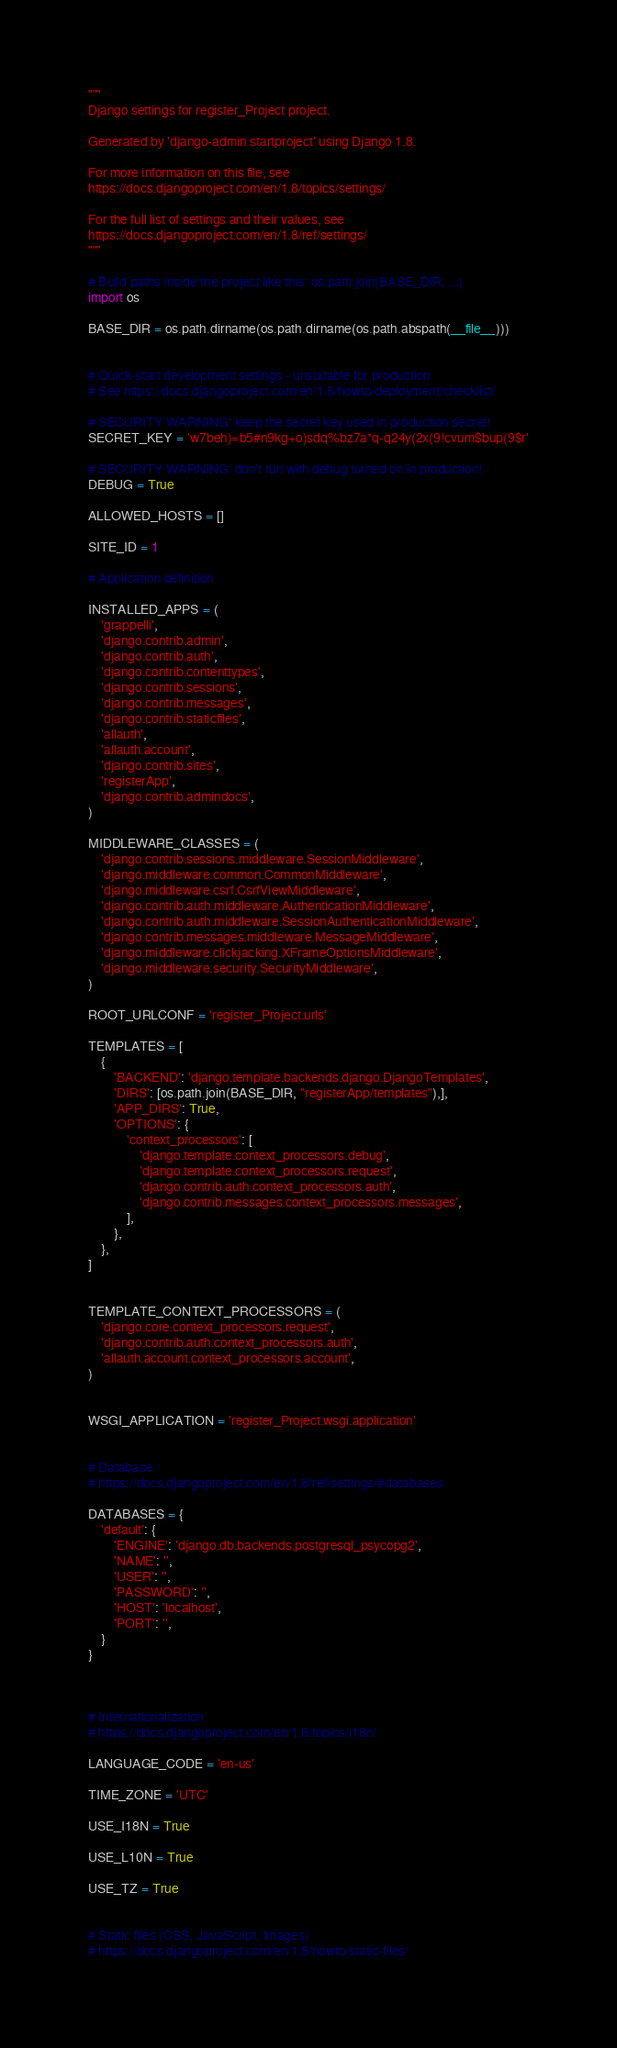<code> <loc_0><loc_0><loc_500><loc_500><_Python_>"""
Django settings for register_Project project.

Generated by 'django-admin startproject' using Django 1.8.

For more information on this file, see
https://docs.djangoproject.com/en/1.8/topics/settings/

For the full list of settings and their values, see
https://docs.djangoproject.com/en/1.8/ref/settings/
"""

# Build paths inside the project like this: os.path.join(BASE_DIR, ...)
import os

BASE_DIR = os.path.dirname(os.path.dirname(os.path.abspath(__file__)))


# Quick-start development settings - unsuitable for production
# See https://docs.djangoproject.com/en/1.8/howto/deployment/checklist/

# SECURITY WARNING: keep the secret key used in production secret!
SECRET_KEY = 'w7beh)=b5#n9kg+o)sdq%bz7a*q-q24y(2x(9!cvum$bup(9$r'

# SECURITY WARNING: don't run with debug turned on in production!
DEBUG = True

ALLOWED_HOSTS = []

SITE_ID = 1

# Application definition

INSTALLED_APPS = (
    'grappelli',
    'django.contrib.admin',
    'django.contrib.auth',
    'django.contrib.contenttypes',
    'django.contrib.sessions',
    'django.contrib.messages',
    'django.contrib.staticfiles',
    'allauth',
    'allauth.account',
    'django.contrib.sites',
    'registerApp',  
    'django.contrib.admindocs',  
)

MIDDLEWARE_CLASSES = (
    'django.contrib.sessions.middleware.SessionMiddleware',
    'django.middleware.common.CommonMiddleware',
    'django.middleware.csrf.CsrfViewMiddleware',
    'django.contrib.auth.middleware.AuthenticationMiddleware',
    'django.contrib.auth.middleware.SessionAuthenticationMiddleware',
    'django.contrib.messages.middleware.MessageMiddleware',
    'django.middleware.clickjacking.XFrameOptionsMiddleware',
    'django.middleware.security.SecurityMiddleware',
)

ROOT_URLCONF = 'register_Project.urls'

TEMPLATES = [
    {
        'BACKEND': 'django.template.backends.django.DjangoTemplates',
        'DIRS': [os.path.join(BASE_DIR, "registerApp/templates"),],
        'APP_DIRS': True,
        'OPTIONS': {
            'context_processors': [
                'django.template.context_processors.debug',
                'django.template.context_processors.request',
                'django.contrib.auth.context_processors.auth',
                'django.contrib.messages.context_processors.messages',
            ],
        },
    },
]


TEMPLATE_CONTEXT_PROCESSORS = (
    'django.core.context_processors.request',
    'django.contrib.auth.context_processors.auth',
    'allauth.account.context_processors.account',
)


WSGI_APPLICATION = 'register_Project.wsgi.application'


# Database
# https://docs.djangoproject.com/en/1.8/ref/settings/#databases

DATABASES = {
    'default': {
        'ENGINE': 'django.db.backends.postgresql_psycopg2',
        'NAME': '',
        'USER': '',
        'PASSWORD': '',
        'HOST': 'localhost',
        'PORT': '',
    }
}



# Internationalization
# https://docs.djangoproject.com/en/1.8/topics/i18n/

LANGUAGE_CODE = 'en-us'

TIME_ZONE = 'UTC'

USE_I18N = True

USE_L10N = True

USE_TZ = True


# Static files (CSS, JavaScript, Images)
# https://docs.djangoproject.com/en/1.8/howto/static-files/
</code> 